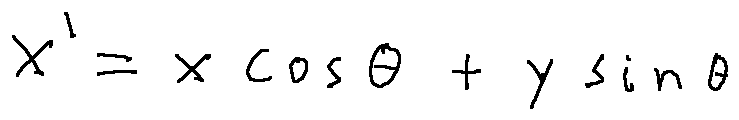Convert formula to latex. <formula><loc_0><loc_0><loc_500><loc_500>x ^ { \prime } = x \cos \theta + y \sin \theta</formula> 